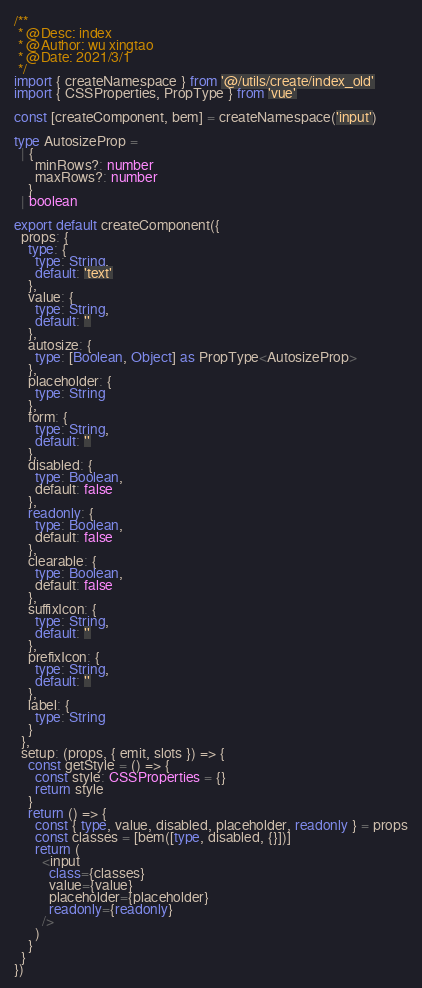Convert code to text. <code><loc_0><loc_0><loc_500><loc_500><_TypeScript_>/**
 * @Desc: index
 * @Author: wu xingtao
 * @Date: 2021/3/1
 */
import { createNamespace } from '@/utils/create/index_old'
import { CSSProperties, PropType } from 'vue'

const [createComponent, bem] = createNamespace('input')

type AutosizeProp =
  | {
      minRows?: number
      maxRows?: number
    }
  | boolean

export default createComponent({
  props: {
    type: {
      type: String,
      default: 'text'
    },
    value: {
      type: String,
      default: ''
    },
    autosize: {
      type: [Boolean, Object] as PropType<AutosizeProp>
    },
    placeholder: {
      type: String
    },
    form: {
      type: String,
      default: ''
    },
    disabled: {
      type: Boolean,
      default: false
    },
    readonly: {
      type: Boolean,
      default: false
    },
    clearable: {
      type: Boolean,
      default: false
    },
    suffixIcon: {
      type: String,
      default: ''
    },
    prefixIcon: {
      type: String,
      default: ''
    },
    label: {
      type: String
    }
  },
  setup: (props, { emit, slots }) => {
    const getStyle = () => {
      const style: CSSProperties = {}
      return style
    }
    return () => {
      const { type, value, disabled, placeholder, readonly } = props
      const classes = [bem([type, disabled, {}])]
      return (
        <input
          class={classes}
          value={value}
          placeholder={placeholder}
          readonly={readonly}
        />
      )
    }
  }
})
</code> 